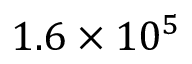<formula> <loc_0><loc_0><loc_500><loc_500>1 . 6 \times 1 0 ^ { 5 }</formula> 